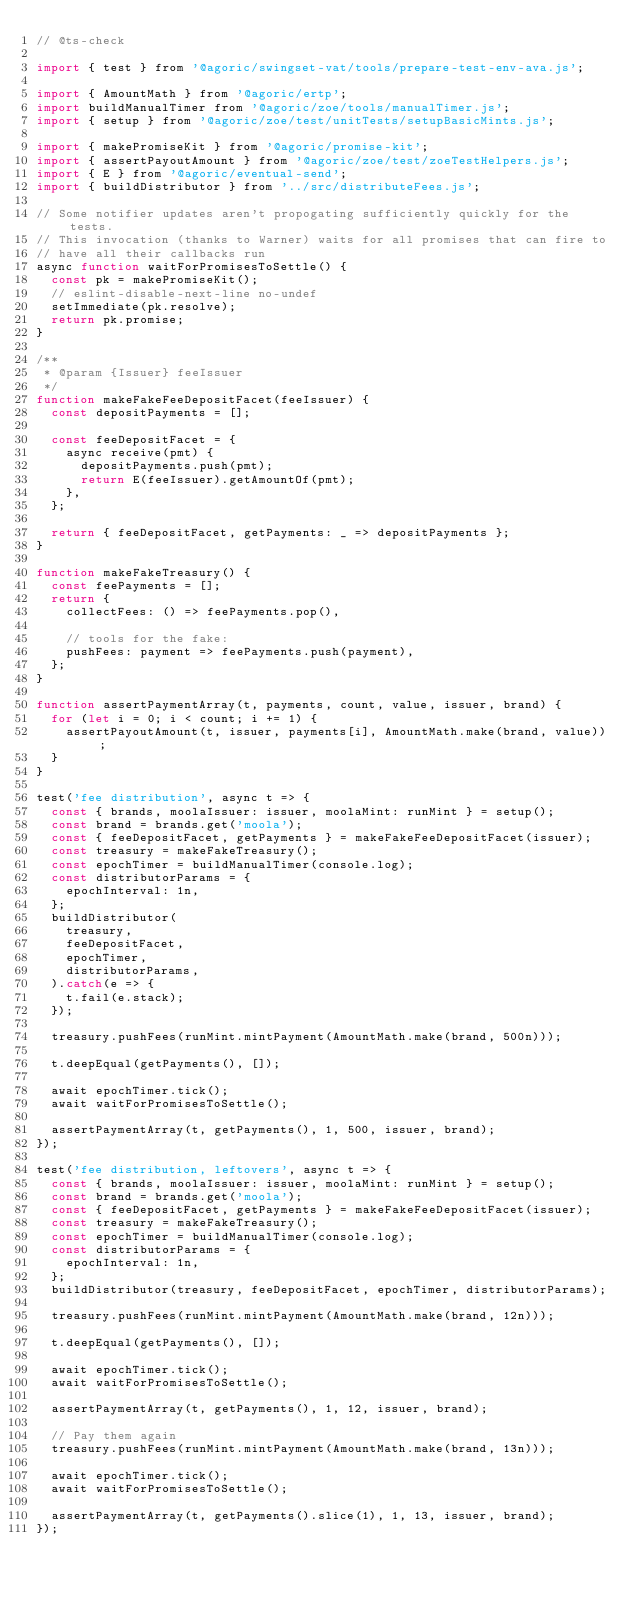Convert code to text. <code><loc_0><loc_0><loc_500><loc_500><_JavaScript_>// @ts-check

import { test } from '@agoric/swingset-vat/tools/prepare-test-env-ava.js';

import { AmountMath } from '@agoric/ertp';
import buildManualTimer from '@agoric/zoe/tools/manualTimer.js';
import { setup } from '@agoric/zoe/test/unitTests/setupBasicMints.js';

import { makePromiseKit } from '@agoric/promise-kit';
import { assertPayoutAmount } from '@agoric/zoe/test/zoeTestHelpers.js';
import { E } from '@agoric/eventual-send';
import { buildDistributor } from '../src/distributeFees.js';

// Some notifier updates aren't propogating sufficiently quickly for the tests.
// This invocation (thanks to Warner) waits for all promises that can fire to
// have all their callbacks run
async function waitForPromisesToSettle() {
  const pk = makePromiseKit();
  // eslint-disable-next-line no-undef
  setImmediate(pk.resolve);
  return pk.promise;
}

/**
 * @param {Issuer} feeIssuer
 */
function makeFakeFeeDepositFacet(feeIssuer) {
  const depositPayments = [];

  const feeDepositFacet = {
    async receive(pmt) {
      depositPayments.push(pmt);
      return E(feeIssuer).getAmountOf(pmt);
    },
  };

  return { feeDepositFacet, getPayments: _ => depositPayments };
}

function makeFakeTreasury() {
  const feePayments = [];
  return {
    collectFees: () => feePayments.pop(),

    // tools for the fake:
    pushFees: payment => feePayments.push(payment),
  };
}

function assertPaymentArray(t, payments, count, value, issuer, brand) {
  for (let i = 0; i < count; i += 1) {
    assertPayoutAmount(t, issuer, payments[i], AmountMath.make(brand, value));
  }
}

test('fee distribution', async t => {
  const { brands, moolaIssuer: issuer, moolaMint: runMint } = setup();
  const brand = brands.get('moola');
  const { feeDepositFacet, getPayments } = makeFakeFeeDepositFacet(issuer);
  const treasury = makeFakeTreasury();
  const epochTimer = buildManualTimer(console.log);
  const distributorParams = {
    epochInterval: 1n,
  };
  buildDistributor(
    treasury,
    feeDepositFacet,
    epochTimer,
    distributorParams,
  ).catch(e => {
    t.fail(e.stack);
  });

  treasury.pushFees(runMint.mintPayment(AmountMath.make(brand, 500n)));

  t.deepEqual(getPayments(), []);

  await epochTimer.tick();
  await waitForPromisesToSettle();

  assertPaymentArray(t, getPayments(), 1, 500, issuer, brand);
});

test('fee distribution, leftovers', async t => {
  const { brands, moolaIssuer: issuer, moolaMint: runMint } = setup();
  const brand = brands.get('moola');
  const { feeDepositFacet, getPayments } = makeFakeFeeDepositFacet(issuer);
  const treasury = makeFakeTreasury();
  const epochTimer = buildManualTimer(console.log);
  const distributorParams = {
    epochInterval: 1n,
  };
  buildDistributor(treasury, feeDepositFacet, epochTimer, distributorParams);

  treasury.pushFees(runMint.mintPayment(AmountMath.make(brand, 12n)));

  t.deepEqual(getPayments(), []);

  await epochTimer.tick();
  await waitForPromisesToSettle();

  assertPaymentArray(t, getPayments(), 1, 12, issuer, brand);

  // Pay them again
  treasury.pushFees(runMint.mintPayment(AmountMath.make(brand, 13n)));

  await epochTimer.tick();
  await waitForPromisesToSettle();

  assertPaymentArray(t, getPayments().slice(1), 1, 13, issuer, brand);
});
</code> 